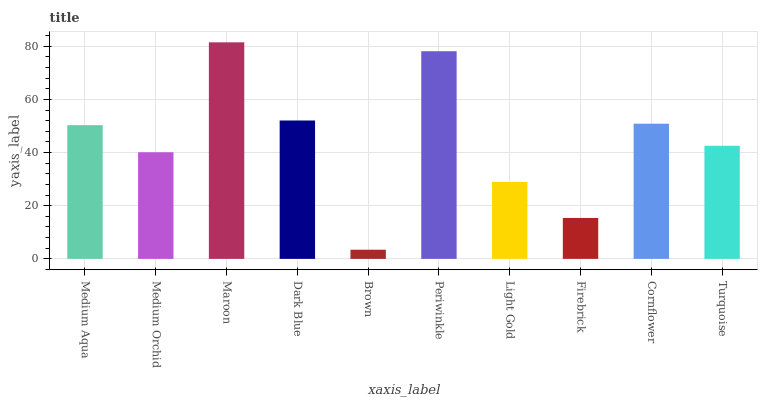Is Brown the minimum?
Answer yes or no. Yes. Is Maroon the maximum?
Answer yes or no. Yes. Is Medium Orchid the minimum?
Answer yes or no. No. Is Medium Orchid the maximum?
Answer yes or no. No. Is Medium Aqua greater than Medium Orchid?
Answer yes or no. Yes. Is Medium Orchid less than Medium Aqua?
Answer yes or no. Yes. Is Medium Orchid greater than Medium Aqua?
Answer yes or no. No. Is Medium Aqua less than Medium Orchid?
Answer yes or no. No. Is Medium Aqua the high median?
Answer yes or no. Yes. Is Turquoise the low median?
Answer yes or no. Yes. Is Turquoise the high median?
Answer yes or no. No. Is Dark Blue the low median?
Answer yes or no. No. 